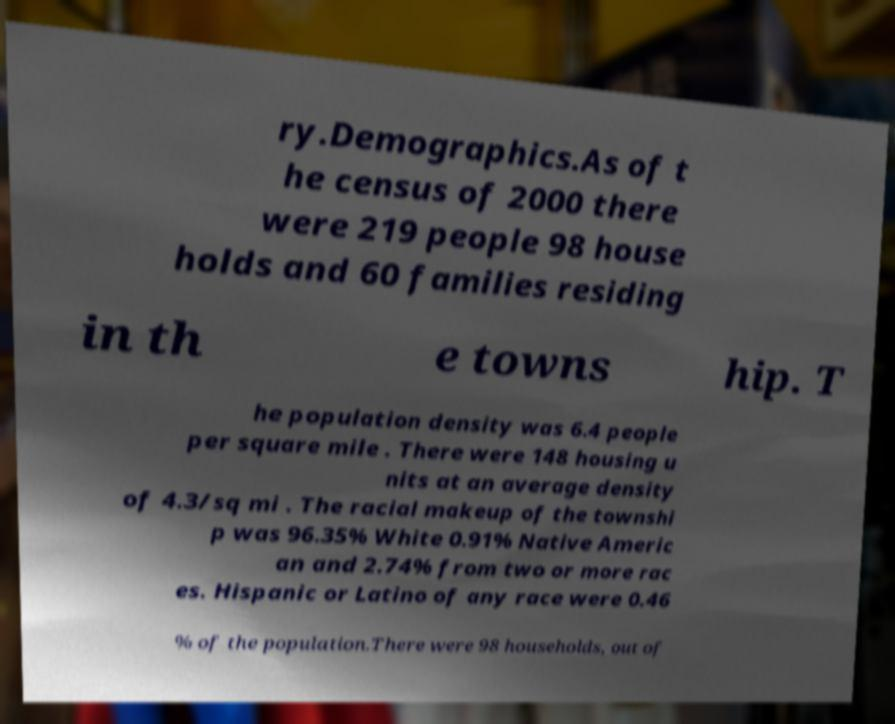Please identify and transcribe the text found in this image. ry.Demographics.As of t he census of 2000 there were 219 people 98 house holds and 60 families residing in th e towns hip. T he population density was 6.4 people per square mile . There were 148 housing u nits at an average density of 4.3/sq mi . The racial makeup of the townshi p was 96.35% White 0.91% Native Americ an and 2.74% from two or more rac es. Hispanic or Latino of any race were 0.46 % of the population.There were 98 households, out of 